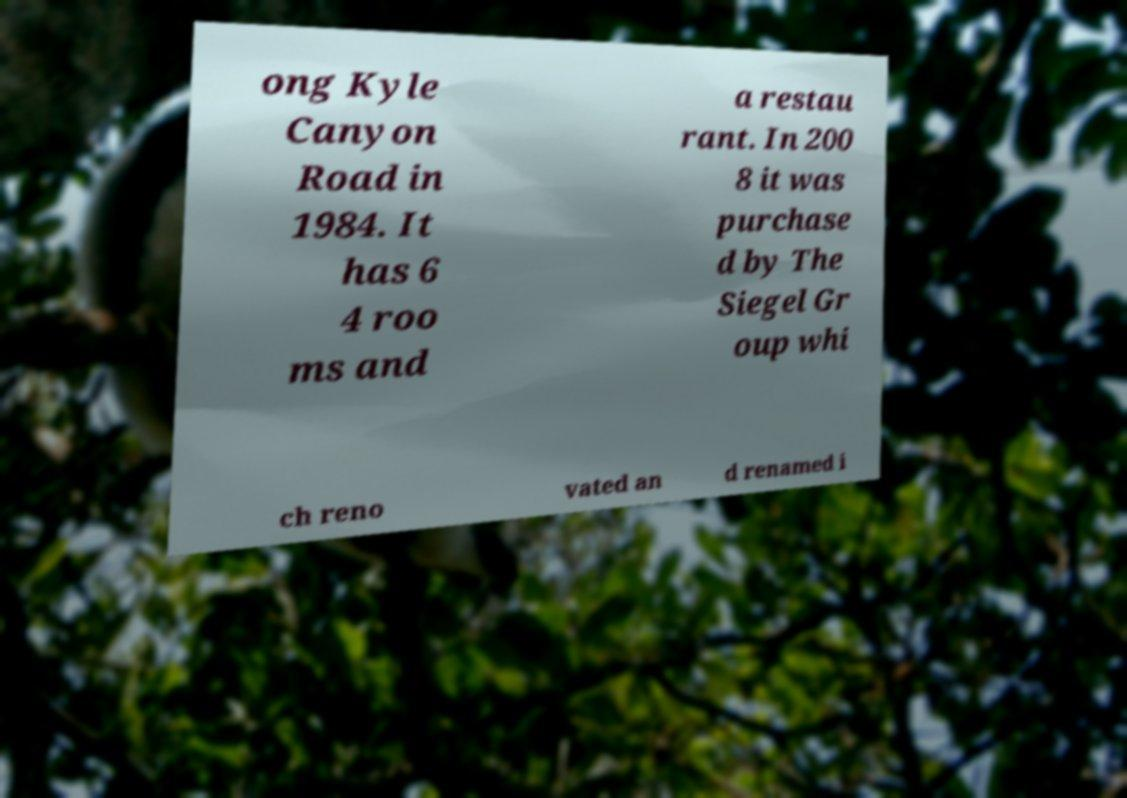Please identify and transcribe the text found in this image. ong Kyle Canyon Road in 1984. It has 6 4 roo ms and a restau rant. In 200 8 it was purchase d by The Siegel Gr oup whi ch reno vated an d renamed i 